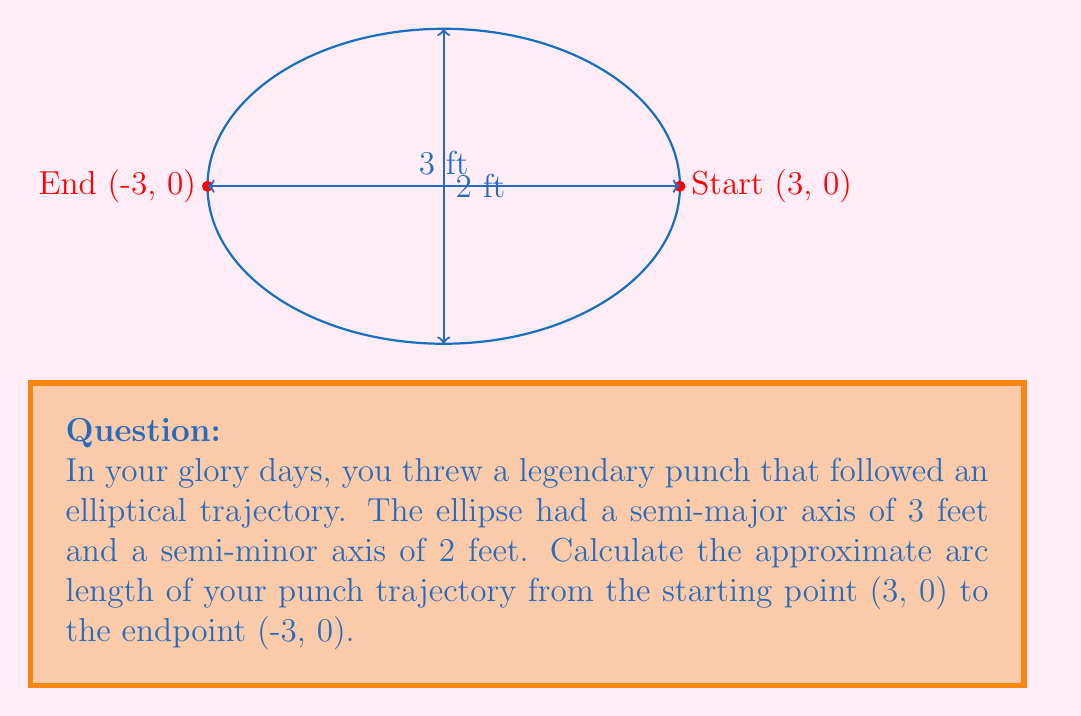Show me your answer to this math problem. Let's approach this step-by-step:

1) The general formula for the arc length of an ellipse is:

   $$L \approx 4a\int_0^{\pi/2} \sqrt{1 - e^2\sin^2\theta} d\theta$$

   Where $a$ is the semi-major axis and $e$ is the eccentricity.

2) We know $a = 3$ feet. We need to calculate the eccentricity $e$:

   $$e = \sqrt{1 - \frac{b^2}{a^2}} = \sqrt{1 - \frac{2^2}{3^2}} = \sqrt{1 - \frac{4}{9}} = \sqrt{\frac{5}{9}} \approx 0.745$$

3) Substituting these values into the arc length formula:

   $$L \approx 4(3)\int_0^{\pi/2} \sqrt{1 - (\frac{5}{9})\sin^2\theta} d\theta$$

4) This integral doesn't have an elementary antiderivative. We can approximate it using numerical methods or elliptic integrals. Using a calculator or computer, we get:

   $$\int_0^{\pi/2} \sqrt{1 - (\frac{5}{9})\sin^2\theta} d\theta \approx 1.3506$$

5) Multiplying by 4a:

   $$L \approx 4(3)(1.3506) = 16.2072 \text{ feet}$$

6) However, this is the length of the full ellipse. We only want half of it (from (3,0) to (-3,0)), so we divide by 2:

   $$L_{half} \approx 16.2072 / 2 = 8.1036 \text{ feet}$$
Answer: $8.1036$ feet 